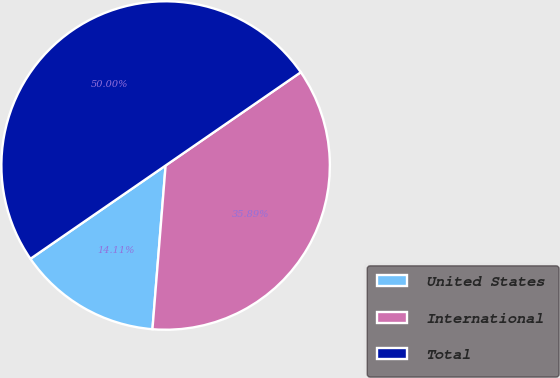Convert chart to OTSL. <chart><loc_0><loc_0><loc_500><loc_500><pie_chart><fcel>United States<fcel>International<fcel>Total<nl><fcel>14.11%<fcel>35.89%<fcel>50.0%<nl></chart> 